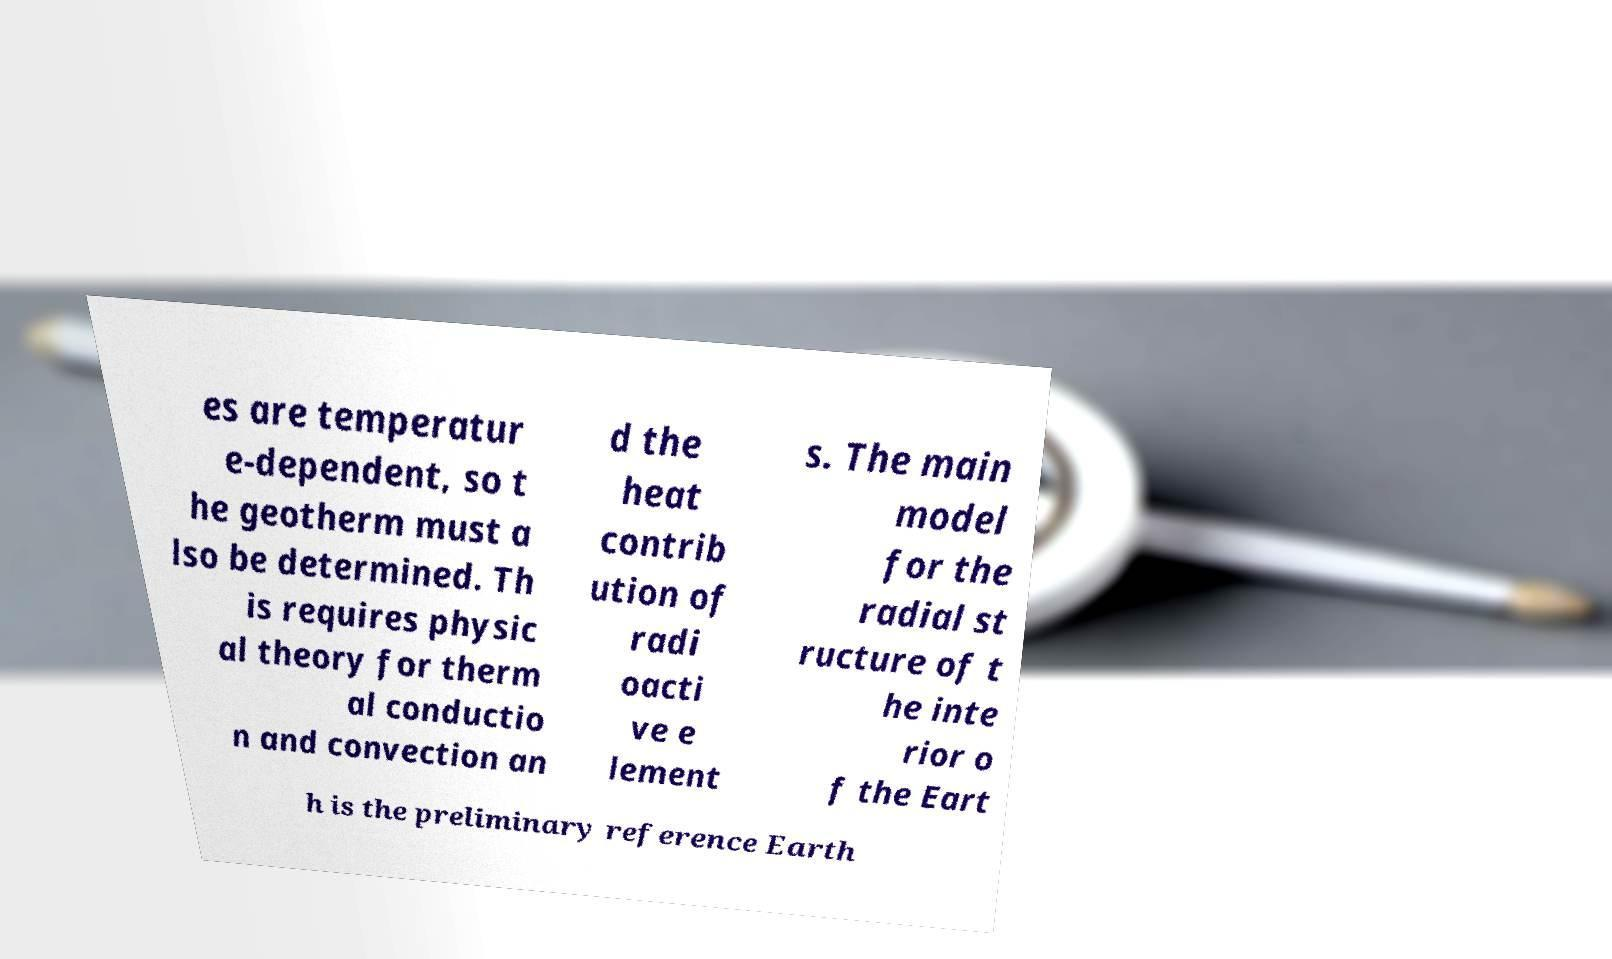Can you read and provide the text displayed in the image?This photo seems to have some interesting text. Can you extract and type it out for me? es are temperatur e-dependent, so t he geotherm must a lso be determined. Th is requires physic al theory for therm al conductio n and convection an d the heat contrib ution of radi oacti ve e lement s. The main model for the radial st ructure of t he inte rior o f the Eart h is the preliminary reference Earth 